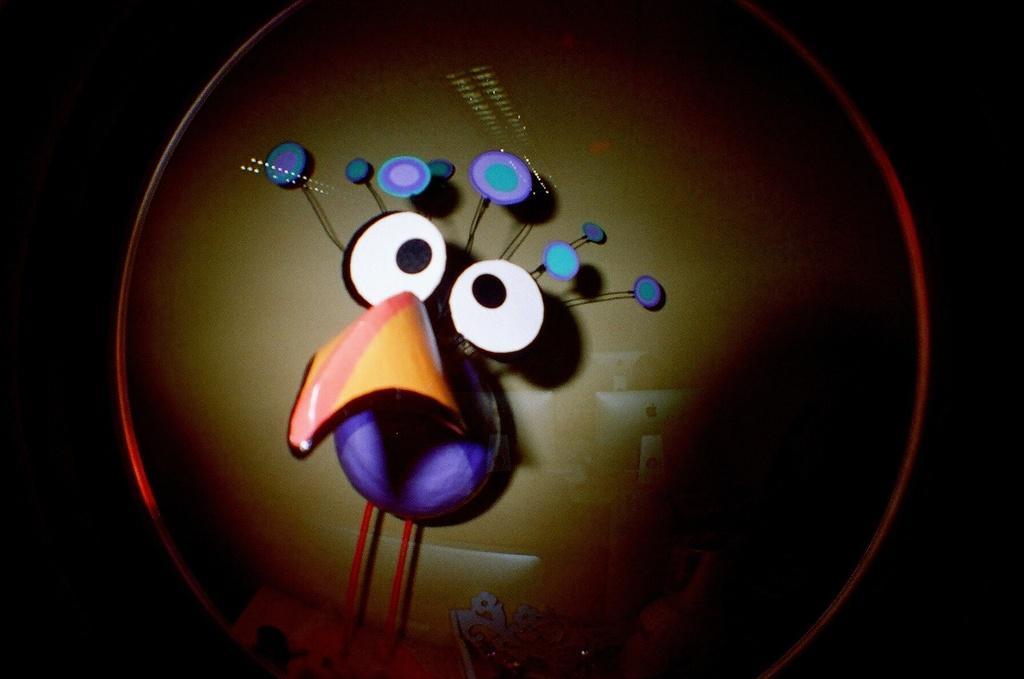In one or two sentences, can you explain what this image depicts? In this image I can see the cartoon picture. In the background I can see few systems. 